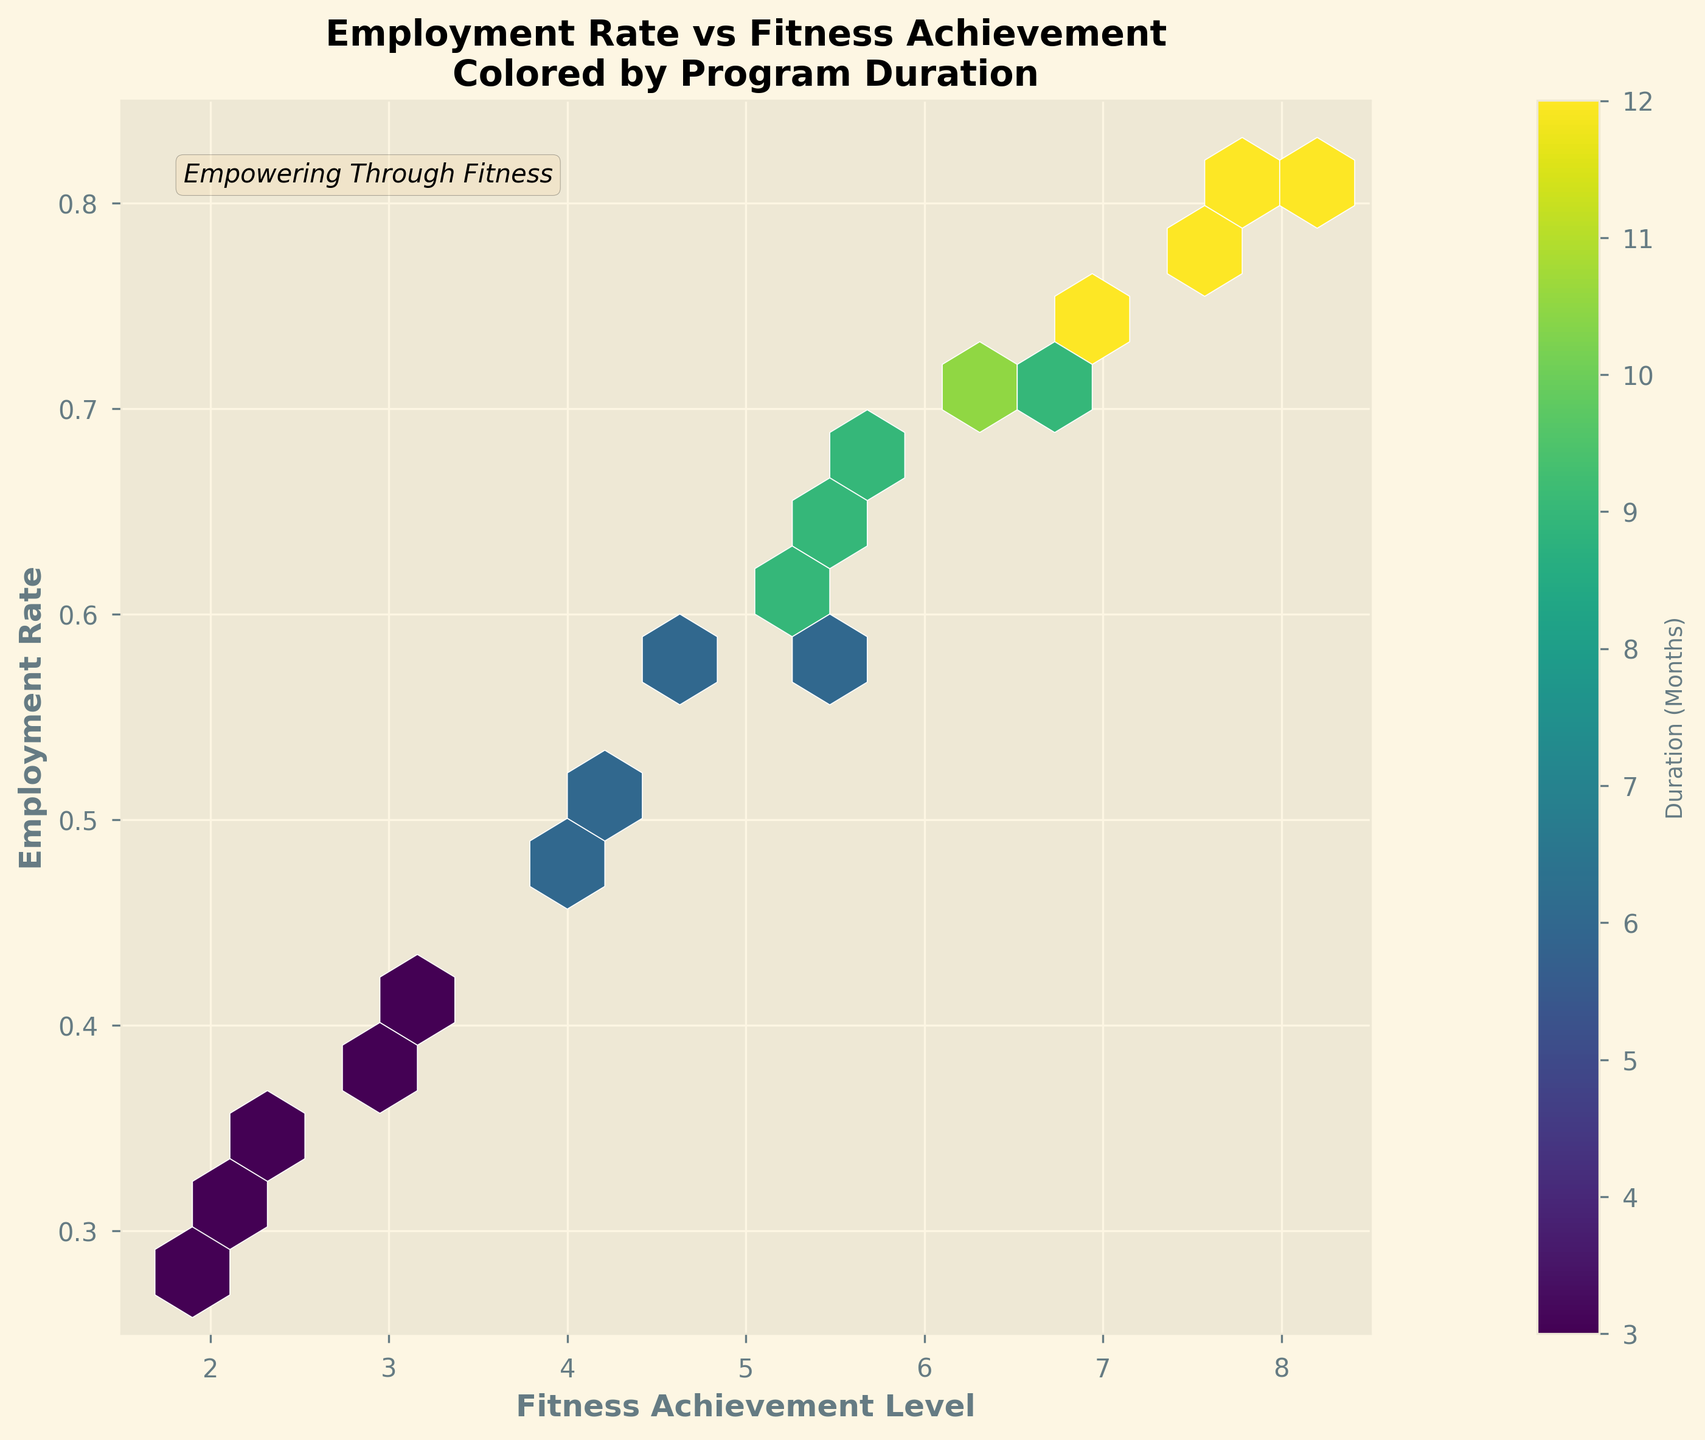What is the title of the hexbin plot? The title is located at the top of the plot and provides an overview of the figure.
Answer: Employment Rate vs Fitness Achievement Colored by Program Duration What are the labels for the x-axis and y-axis? The labels for the axes can be found along the horizontal (x-axis) and vertical (y-axis) lines of the plot. The x-axis label denotes what is being represented on the horizontal axis, while the y-axis label indicates what is on the vertical axis.
Answer: Fitness Achievement Level and Employment Rate What does the color in the hexbin plot represent? The color represents the "Duration (Months)" as indicated by the color bar located to the right side of the plot. The shade of color provides information on the length of participation in the program.
Answer: Duration (Months) How does the duration of participation correlate with employment rates and fitness achievement levels? Higher duration generally corresponds to higher fitness achievement levels and employment rates, as seen from darker hexagons (indicating longer durations) appearing towards the upper-right corner of the plot.
Answer: Positive correlation What is the employment rate range illustrated in the plot? The range of the employment rate can be found on the y-axis, which shows the minimum and maximum values plotted.
Answer: 0.25 to 0.85 What's the general trend between fitness achievement level and employment rate? Observing the data points scattered across the plot, there is a visible upward trend indicating that as fitness achievement levels increase, the employment rate also increases.
Answer: Positive trend Which fitness achievement level has the highest employment rate and what is the corresponding duration? The highest employment rate can be found at the top-right hexagon, which corresponds with the highest fitness achievement level shown in the plot. The color of this hexagon indicates the duration.
Answer: About 8.2 in fitness achievement and 12 months What is the relationship between data density and program duration across different fitness achievement levels? Data density is represented by the concentration of hexagons. Higher density is indicated by a grouping of hexagons, and their color shows the duration. You can observe moderate to high-density regions with longer durations generally in higher fitness achievement levels.
Answer: Higher density at higher fitness levels with longer durations How does a 6-month duration compare to different fitness achievement levels in terms of employment rates? Examining the color corresponding to 6 months, employment rates range approximately between 0.47 and 0.59 for fitness achievement ranging from 3.8 to 5.3.
Answer: Employment rates range from 0.47 to 0.59 Which area in the plot indicates the least employment rate, and what are the corresponding fitness achievement levels and durations? The area with the least employment rate is near the bottom-left corner of the plot. The hexagons in this region are lighter, indicating shorter durations and lower fitness achievement levels.
Answer: Employment rate around 0.28 to 0.35, fitness achievement 1.9 to 2.5, and duration of 3 months 